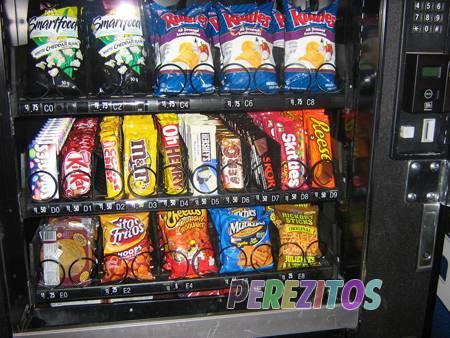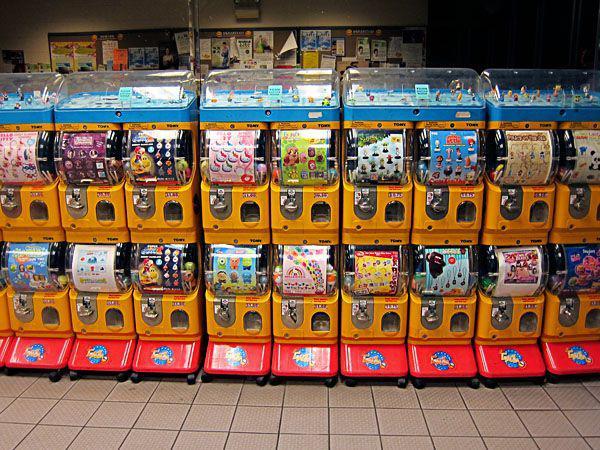The first image is the image on the left, the second image is the image on the right. Given the left and right images, does the statement "An image shows two straight stacked rows of vending machines, at least 8 across." hold true? Answer yes or no. Yes. The first image is the image on the left, the second image is the image on the right. Analyze the images presented: Is the assertion "There are toy vending machines in both images." valid? Answer yes or no. No. 